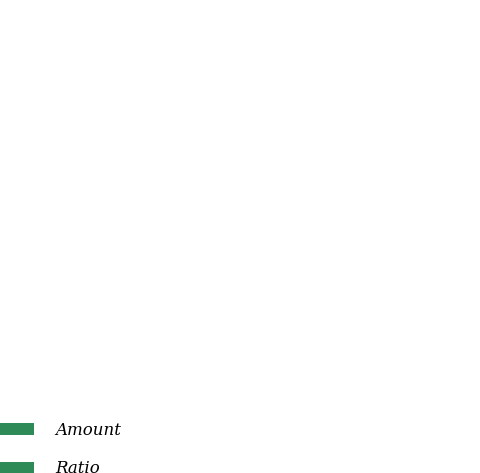Convert chart to OTSL. <chart><loc_0><loc_0><loc_500><loc_500><pie_chart><fcel>Amount<fcel>Ratio<nl><fcel>100.0%<fcel>0.0%<nl></chart> 